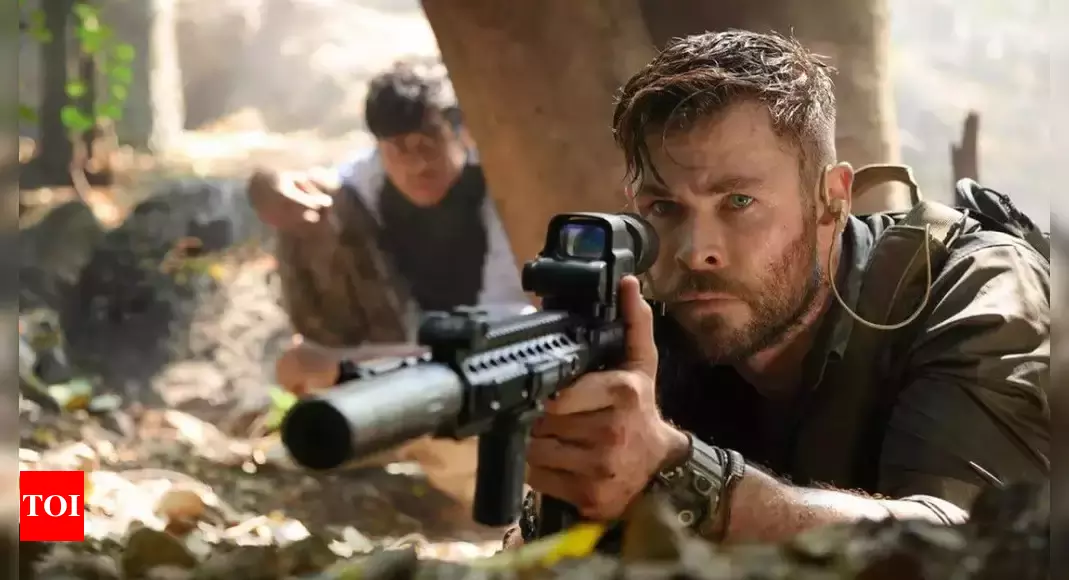Imagine if the characters in the image were actually ancient warriors who time-traveled to the present day. How might they react to the modern environment and technology? Ancient warriors time-traveling to the present day would likely be initially bewildered by their surroundings and the advanced technology. Their first reactions might range from awe to suspicion as they encounter modern weaponry, transportation, and communication devices. Over time, these warriors, guided by their survival instincts, would seek to understand and possibly adapt to these new tools. They might draw parallels between modern and ancient strategies, using their profound combat skills alongside newfound technology to navigate and triumph in the contemporary world. This blending of eras could open up fascinating narrative possibilities, from epic battles to the exchange of timeless wisdom and tactical prowess. 